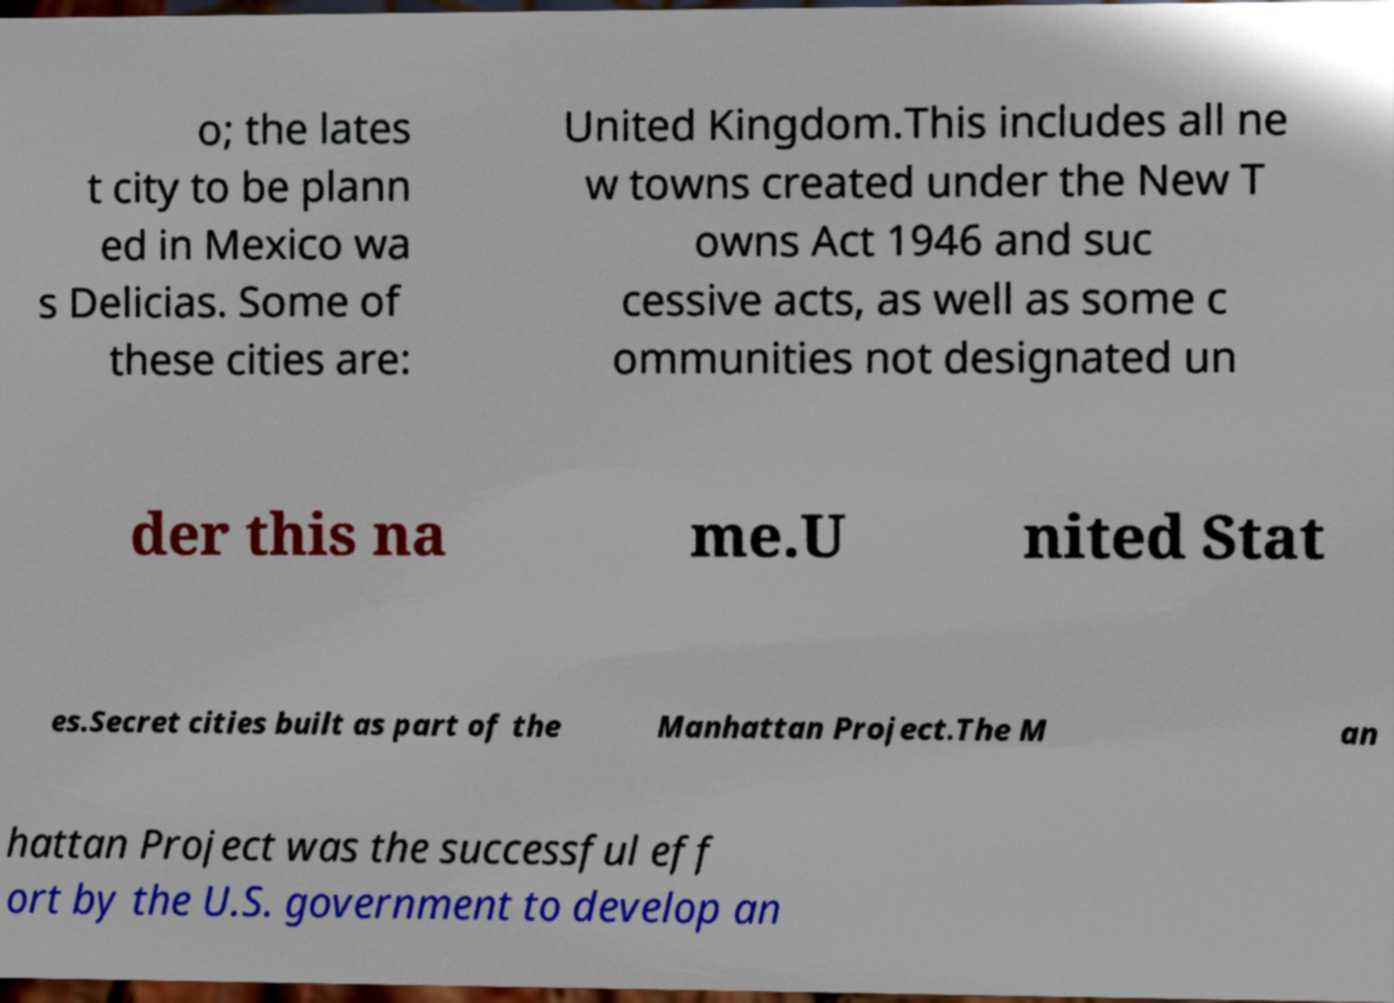Can you read and provide the text displayed in the image?This photo seems to have some interesting text. Can you extract and type it out for me? o; the lates t city to be plann ed in Mexico wa s Delicias. Some of these cities are: United Kingdom.This includes all ne w towns created under the New T owns Act 1946 and suc cessive acts, as well as some c ommunities not designated un der this na me.U nited Stat es.Secret cities built as part of the Manhattan Project.The M an hattan Project was the successful eff ort by the U.S. government to develop an 